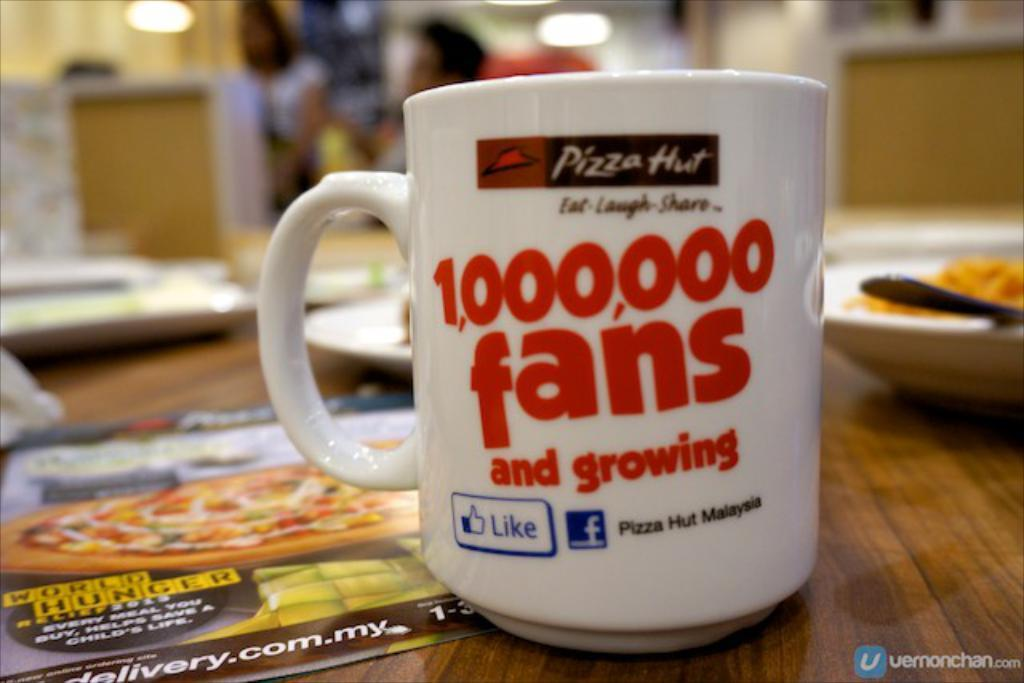<image>
Offer a succinct explanation of the picture presented. A white mug that says 1,000,000 fans and growing on it. 